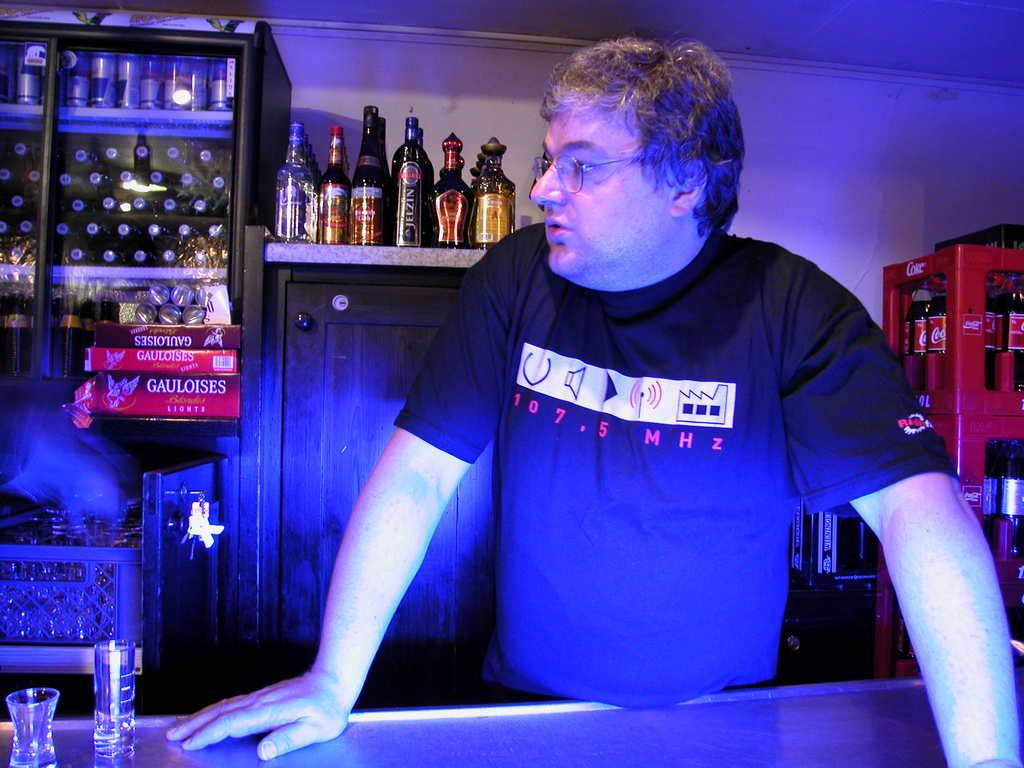Provide a one-sentence caption for the provided image. Man standing at a bar with a shirt reading 107.5 Mhz. 